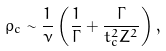Convert formula to latex. <formula><loc_0><loc_0><loc_500><loc_500>\rho _ { c } \sim \frac { 1 } { \nu } \left ( \frac { 1 } { \Gamma } + \frac { \Gamma } { t _ { c } ^ { 2 } Z ^ { 2 } } \right ) ,</formula> 